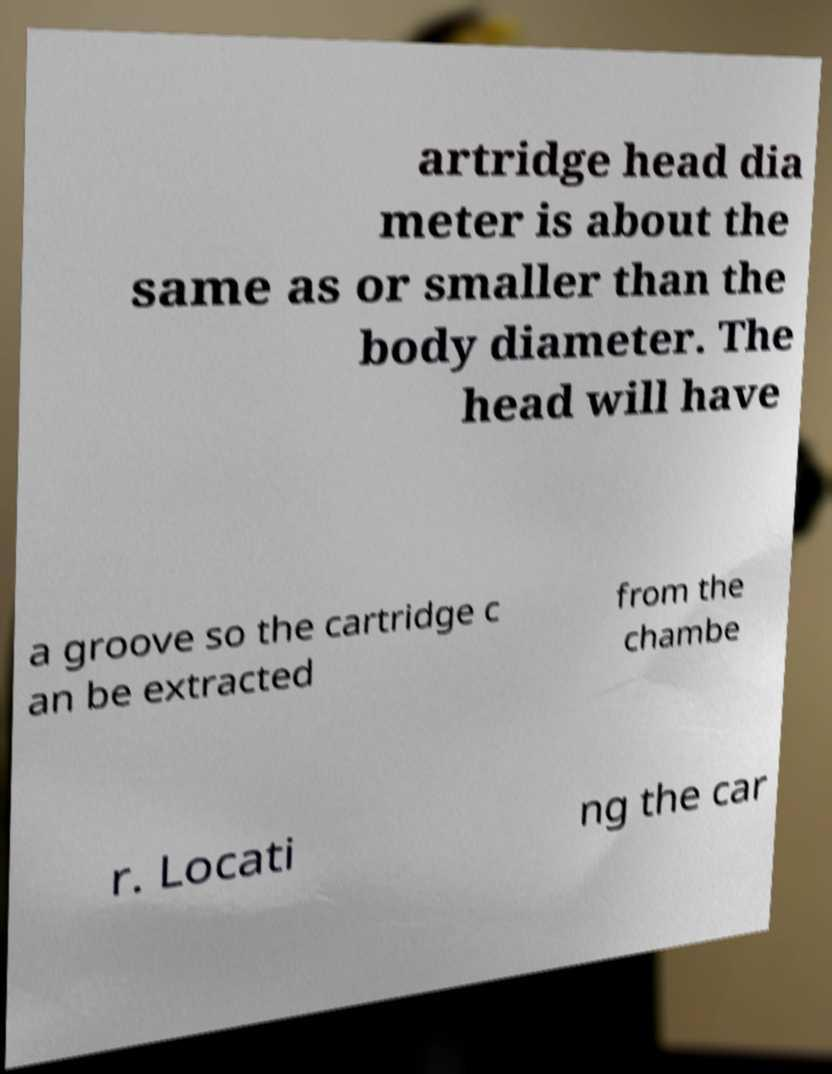I need the written content from this picture converted into text. Can you do that? artridge head dia meter is about the same as or smaller than the body diameter. The head will have a groove so the cartridge c an be extracted from the chambe r. Locati ng the car 